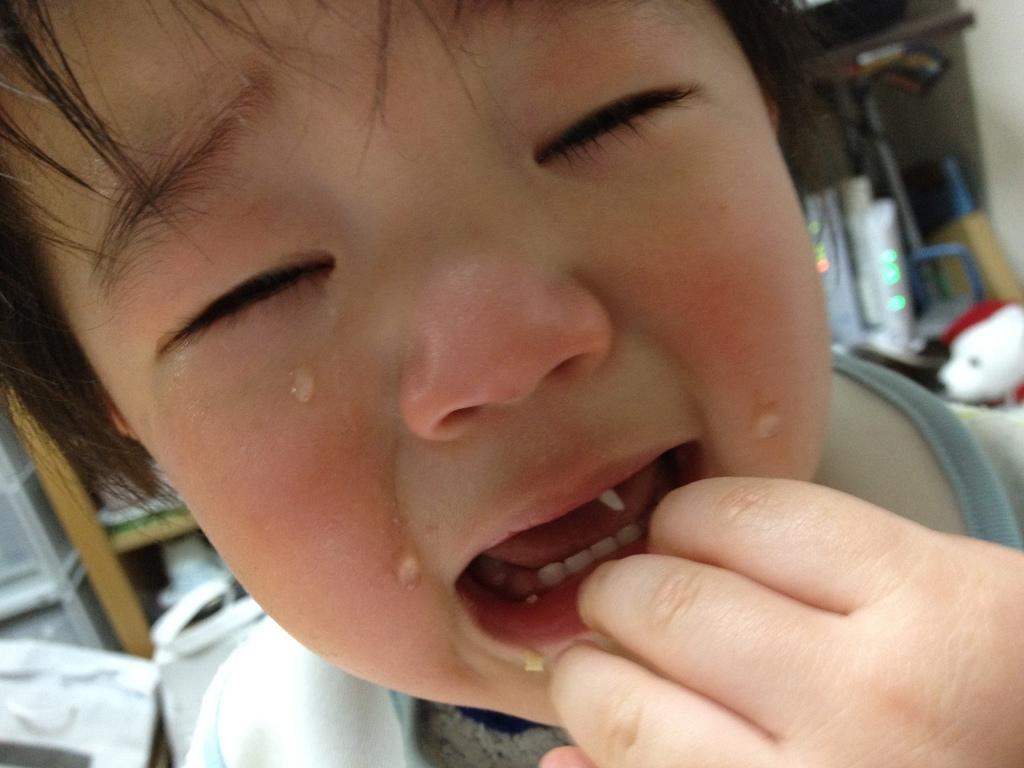Can you describe this image briefly? This baby is crying. Background it is blur. We can see rack, teddy and things. 